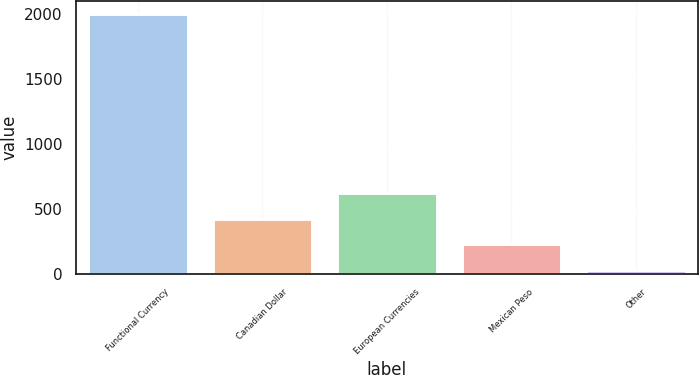Convert chart to OTSL. <chart><loc_0><loc_0><loc_500><loc_500><bar_chart><fcel>Functional Currency<fcel>Canadian Dollar<fcel>European Currencies<fcel>Mexican Peso<fcel>Other<nl><fcel>2002<fcel>427.12<fcel>623.98<fcel>230.26<fcel>33.4<nl></chart> 